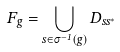Convert formula to latex. <formula><loc_0><loc_0><loc_500><loc_500>F _ { g } = \bigcup _ { s \in \sigma ^ { - 1 } ( g ) } D _ { s s ^ { * } }</formula> 